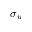<formula> <loc_0><loc_0><loc_500><loc_500>\sigma _ { u }</formula> 